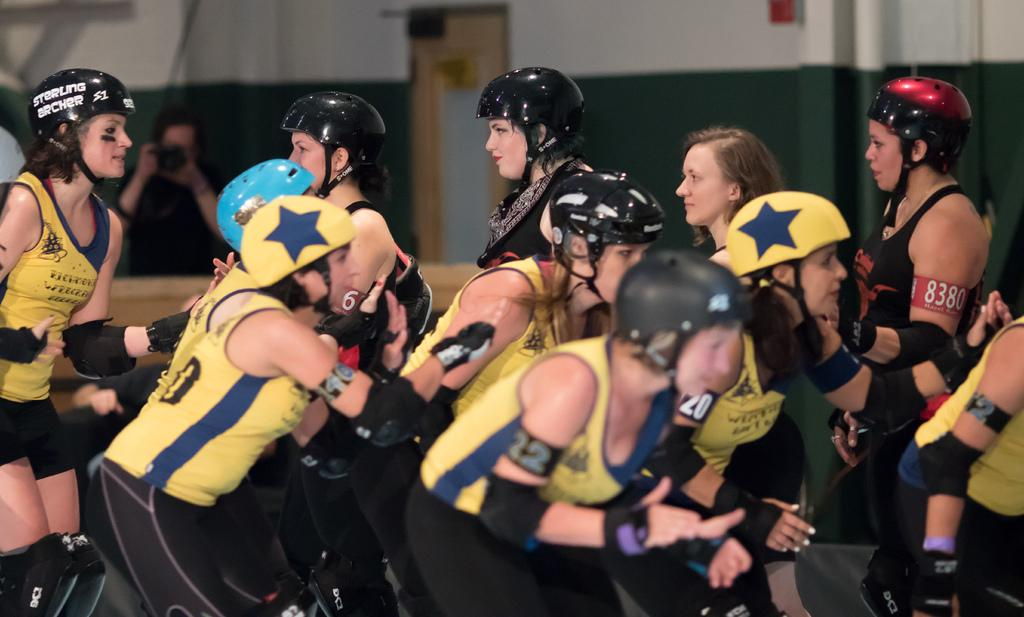How many persons are in the image? There are persons in the image, but the exact number is not specified. What are the persons wearing in the image? The persons are wearing clothes and helmets in the image. What is the background of the image? There is a wall in the image, and a door is visible at the top. What type of egg is being used to bake cakes in the image? There is no egg or mention of cakes in the image; the focus is on the persons, their clothing, and the background. 